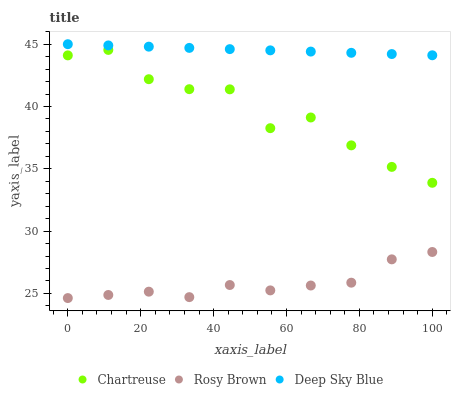Does Rosy Brown have the minimum area under the curve?
Answer yes or no. Yes. Does Deep Sky Blue have the maximum area under the curve?
Answer yes or no. Yes. Does Deep Sky Blue have the minimum area under the curve?
Answer yes or no. No. Does Rosy Brown have the maximum area under the curve?
Answer yes or no. No. Is Deep Sky Blue the smoothest?
Answer yes or no. Yes. Is Chartreuse the roughest?
Answer yes or no. Yes. Is Rosy Brown the smoothest?
Answer yes or no. No. Is Rosy Brown the roughest?
Answer yes or no. No. Does Rosy Brown have the lowest value?
Answer yes or no. Yes. Does Deep Sky Blue have the lowest value?
Answer yes or no. No. Does Deep Sky Blue have the highest value?
Answer yes or no. Yes. Does Rosy Brown have the highest value?
Answer yes or no. No. Is Rosy Brown less than Deep Sky Blue?
Answer yes or no. Yes. Is Deep Sky Blue greater than Rosy Brown?
Answer yes or no. Yes. Does Rosy Brown intersect Deep Sky Blue?
Answer yes or no. No. 